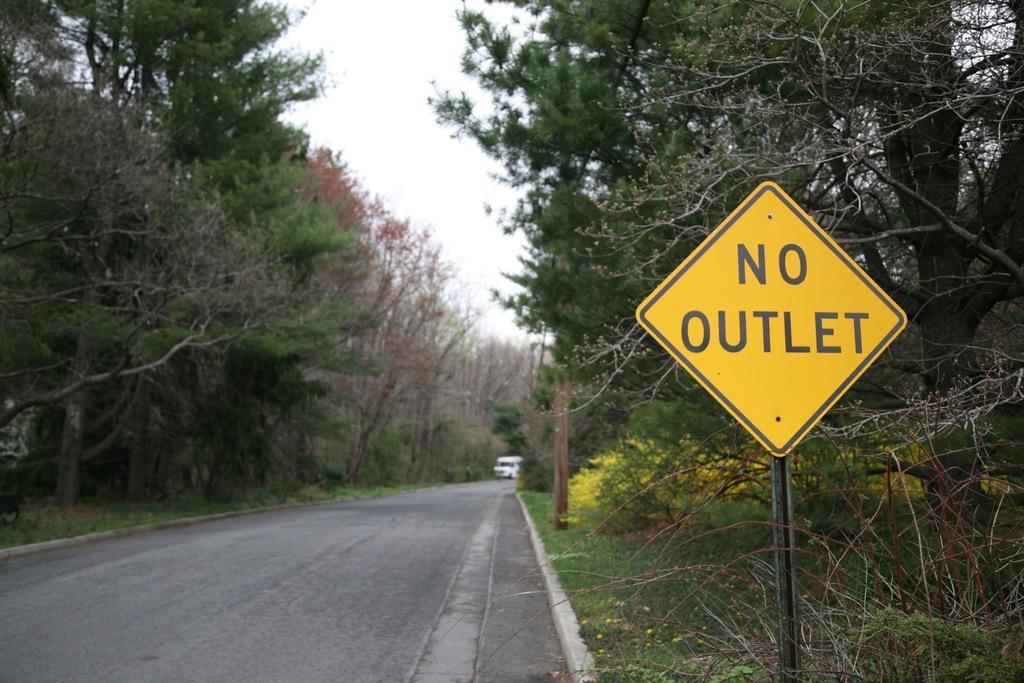Provide a one-sentence caption for the provided image. A yellow sign by the road says that there is no outlet. 